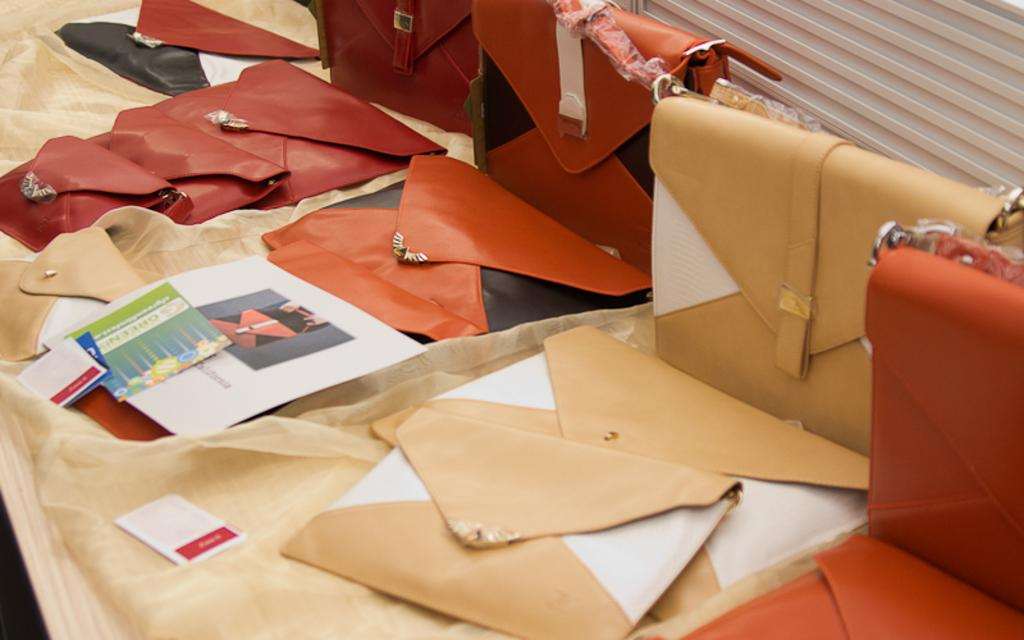What is located in the center of the image? There is a table in the center of the image. What is covering the table? There is a cloth on the table. What items can be seen on the table? Papers, boards, wallets, and bags are on the table. What is visible at the top of the image? There is a wall at the top of the image. Can you see any butter on the table in the image? There is no butter present on the table in the image. How does the edge of the table look like in the image? The edge of the table is not visible in the image, as it is focused on the center of the table. 